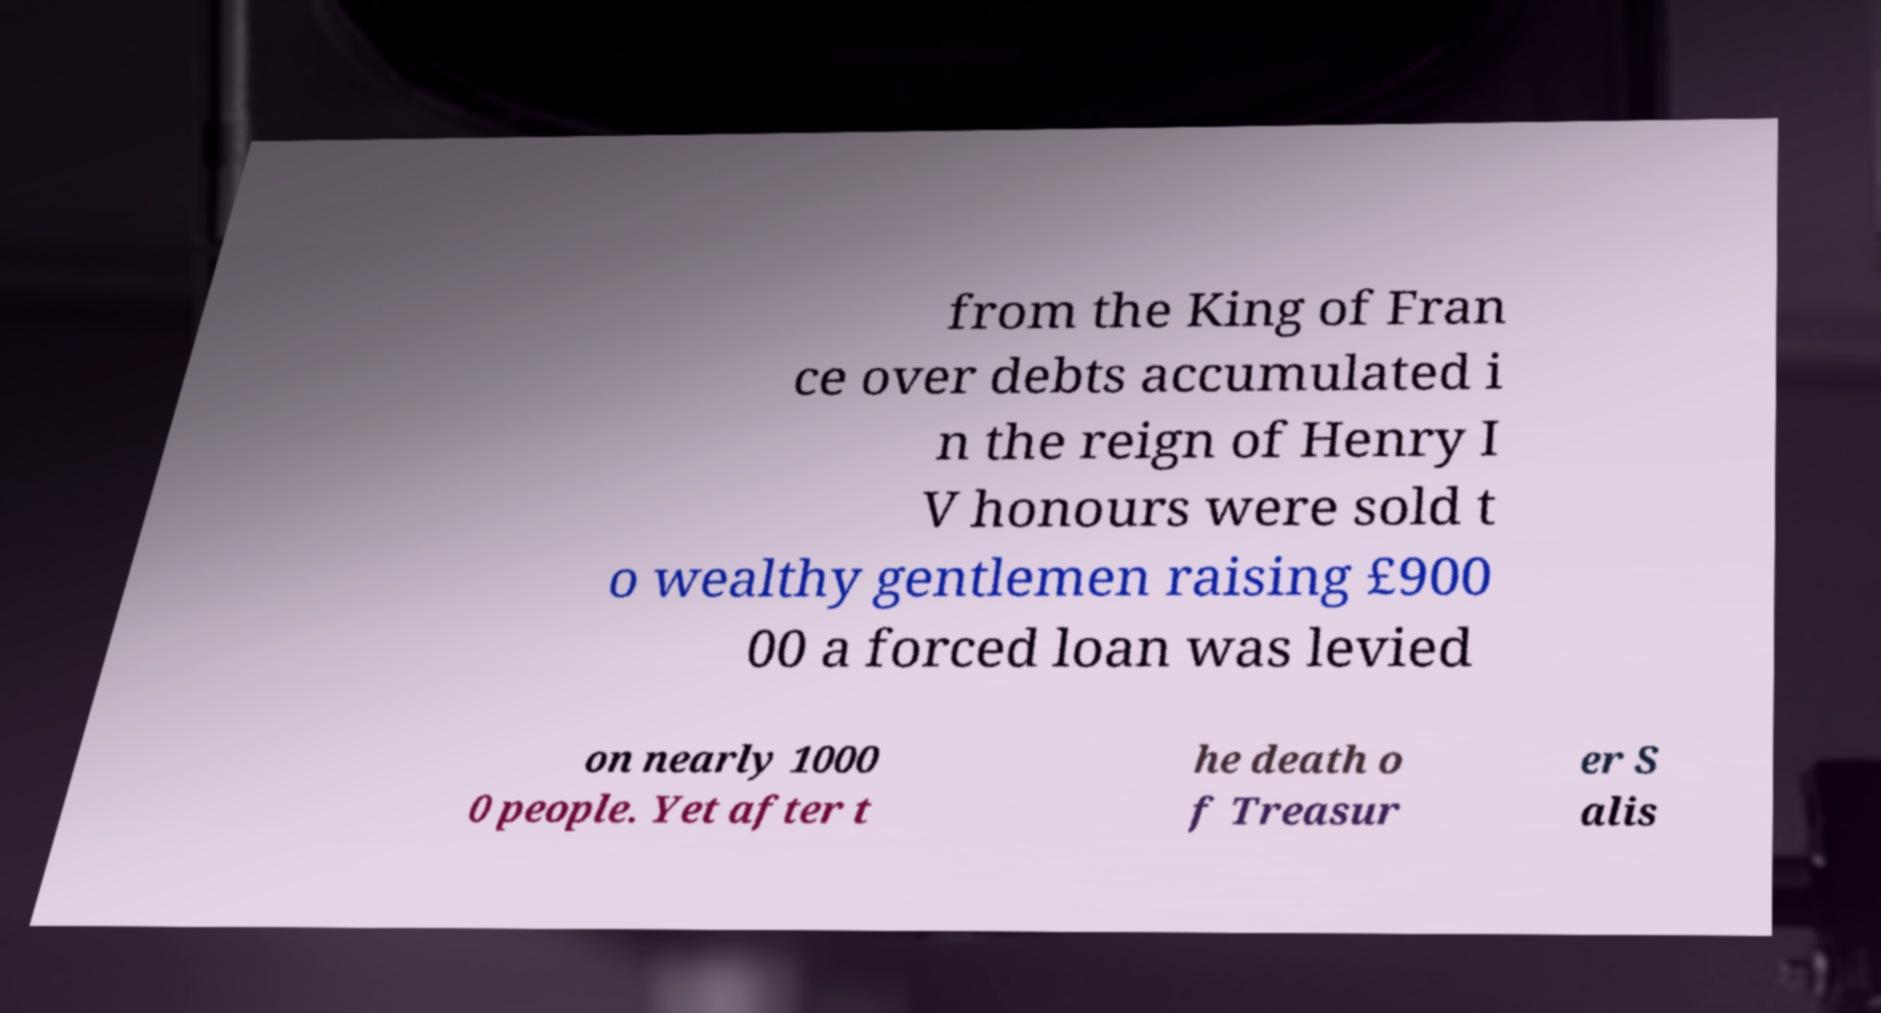Please read and relay the text visible in this image. What does it say? from the King of Fran ce over debts accumulated i n the reign of Henry I V honours were sold t o wealthy gentlemen raising £900 00 a forced loan was levied on nearly 1000 0 people. Yet after t he death o f Treasur er S alis 